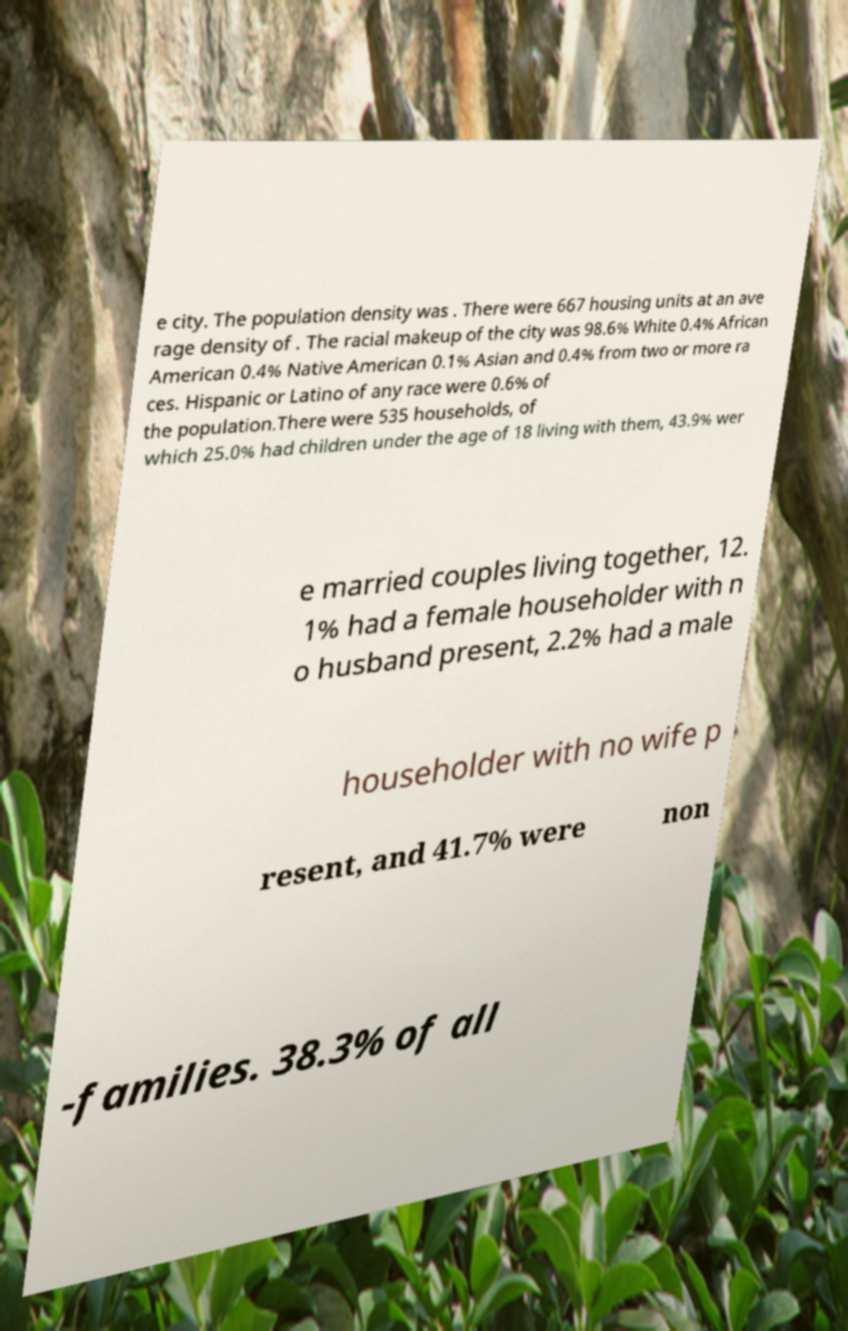For documentation purposes, I need the text within this image transcribed. Could you provide that? e city. The population density was . There were 667 housing units at an ave rage density of . The racial makeup of the city was 98.6% White 0.4% African American 0.4% Native American 0.1% Asian and 0.4% from two or more ra ces. Hispanic or Latino of any race were 0.6% of the population.There were 535 households, of which 25.0% had children under the age of 18 living with them, 43.9% wer e married couples living together, 12. 1% had a female householder with n o husband present, 2.2% had a male householder with no wife p resent, and 41.7% were non -families. 38.3% of all 